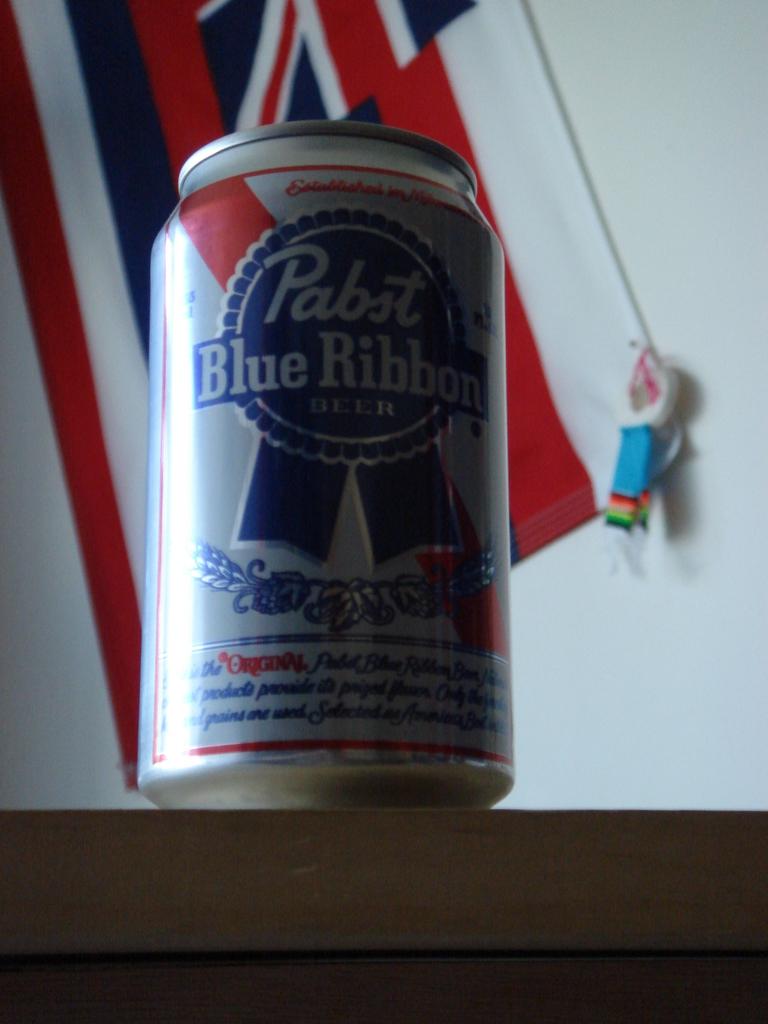What is the brand of beer?
Give a very brief answer. Pabst blue ribbon. What flag is in the background?
Provide a succinct answer. British. 